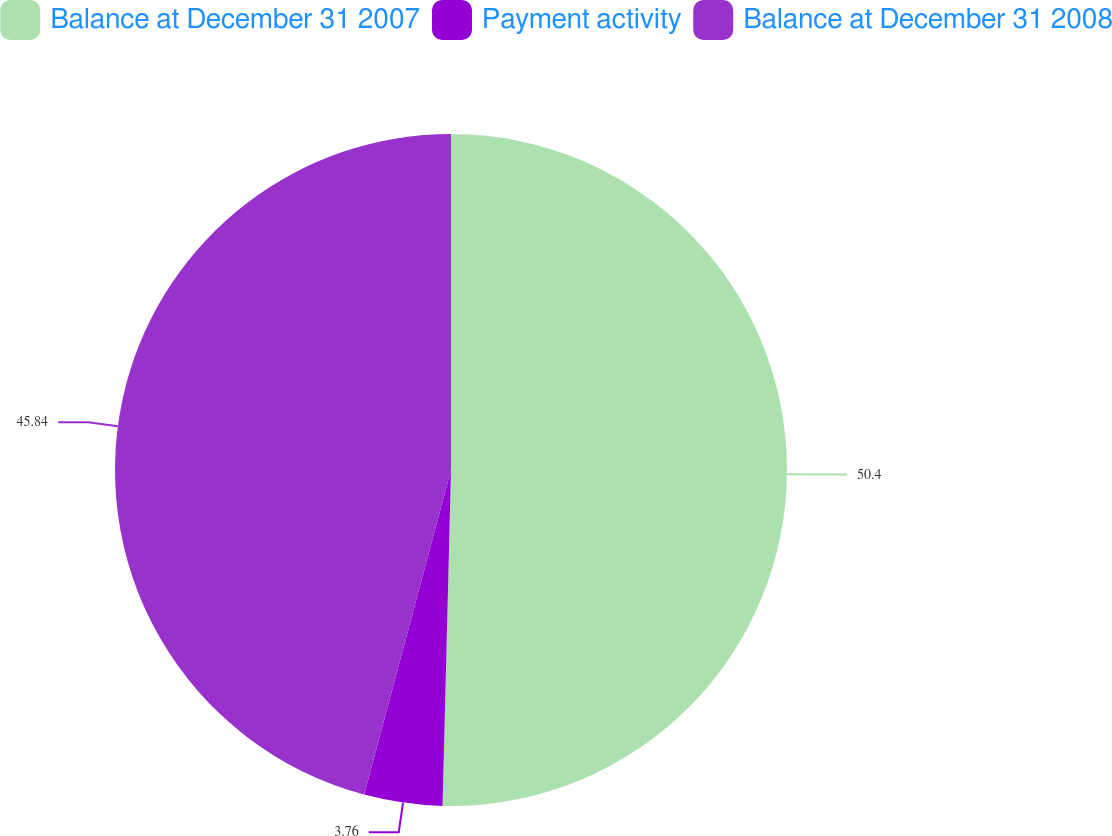<chart> <loc_0><loc_0><loc_500><loc_500><pie_chart><fcel>Balance at December 31 2007<fcel>Payment activity<fcel>Balance at December 31 2008<nl><fcel>50.4%<fcel>3.76%<fcel>45.84%<nl></chart> 